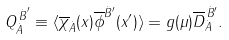<formula> <loc_0><loc_0><loc_500><loc_500>Q _ { \dot { A } } ^ { { \, \dot { B } } ^ { \prime } } \equiv \langle \overline { \chi } _ { \dot { A } } ( x ) \overline { \phi } ^ { { \dot { B } } ^ { \prime } } ( x ^ { \prime } ) \rangle = g ( \mu ) \overline { D } _ { \dot { A } } ^ { \, { \dot { B } ^ { \prime } } } .</formula> 